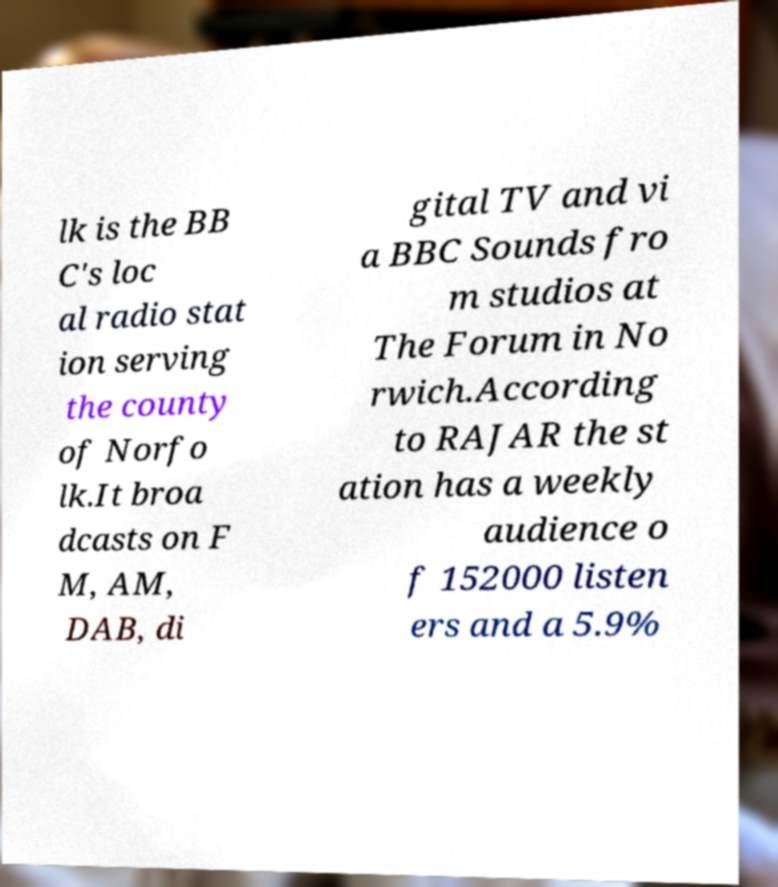Please read and relay the text visible in this image. What does it say? lk is the BB C's loc al radio stat ion serving the county of Norfo lk.It broa dcasts on F M, AM, DAB, di gital TV and vi a BBC Sounds fro m studios at The Forum in No rwich.According to RAJAR the st ation has a weekly audience o f 152000 listen ers and a 5.9% 